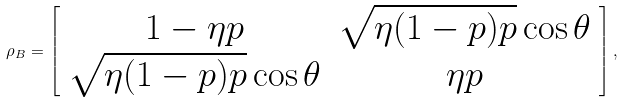<formula> <loc_0><loc_0><loc_500><loc_500>\rho _ { B } = \left [ \begin{array} { c c } 1 - \eta p & \sqrt { \eta ( 1 - p ) p } \cos \theta \\ \sqrt { \eta ( 1 - p ) p } \cos \theta & \eta p \end{array} \right ] ,</formula> 